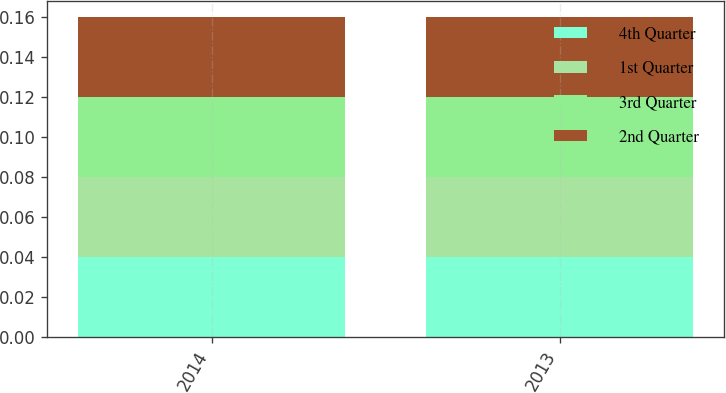<chart> <loc_0><loc_0><loc_500><loc_500><stacked_bar_chart><ecel><fcel>2014<fcel>2013<nl><fcel>4th Quarter<fcel>0.04<fcel>0.04<nl><fcel>1st Quarter<fcel>0.04<fcel>0.04<nl><fcel>3rd Quarter<fcel>0.04<fcel>0.04<nl><fcel>2nd Quarter<fcel>0.04<fcel>0.04<nl></chart> 